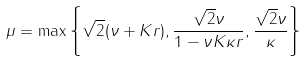Convert formula to latex. <formula><loc_0><loc_0><loc_500><loc_500>\mu = \max \left \{ \sqrt { 2 } ( \nu + K r ) , \frac { \sqrt { 2 } \nu } { 1 - \nu K \kappa r } , \frac { \sqrt { 2 } \nu } { \kappa } \right \}</formula> 